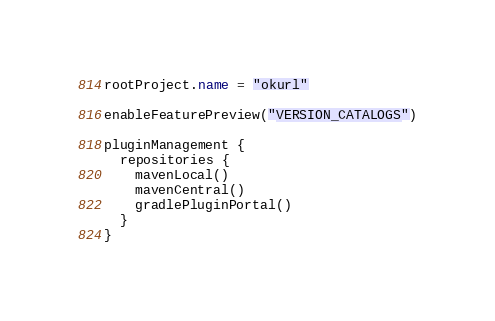Convert code to text. <code><loc_0><loc_0><loc_500><loc_500><_Kotlin_>rootProject.name = "okurl"

enableFeaturePreview("VERSION_CATALOGS")

pluginManagement {
  repositories {
    mavenLocal()
    mavenCentral()
    gradlePluginPortal()
  }
}
</code> 